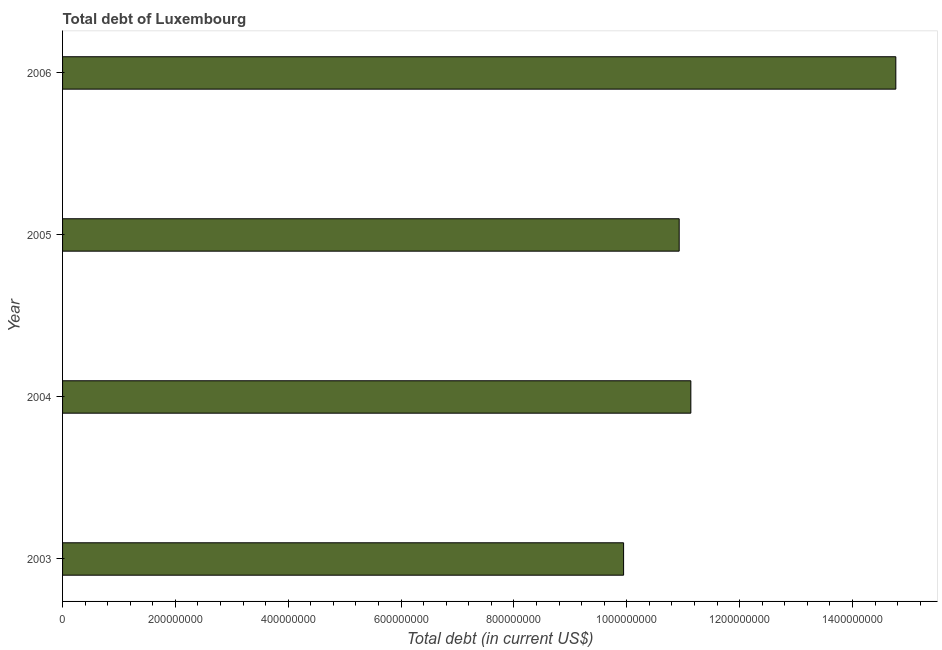What is the title of the graph?
Your answer should be very brief. Total debt of Luxembourg. What is the label or title of the X-axis?
Your answer should be compact. Total debt (in current US$). What is the total debt in 2004?
Give a very brief answer. 1.11e+09. Across all years, what is the maximum total debt?
Your answer should be very brief. 1.48e+09. Across all years, what is the minimum total debt?
Make the answer very short. 9.94e+08. In which year was the total debt minimum?
Your answer should be very brief. 2003. What is the sum of the total debt?
Your response must be concise. 4.68e+09. What is the difference between the total debt in 2004 and 2006?
Your answer should be compact. -3.63e+08. What is the average total debt per year?
Your answer should be very brief. 1.17e+09. What is the median total debt?
Give a very brief answer. 1.10e+09. In how many years, is the total debt greater than 80000000 US$?
Your answer should be compact. 4. What is the ratio of the total debt in 2003 to that in 2004?
Offer a very short reply. 0.89. Is the total debt in 2003 less than that in 2006?
Your answer should be compact. Yes. Is the difference between the total debt in 2004 and 2005 greater than the difference between any two years?
Provide a short and direct response. No. What is the difference between the highest and the second highest total debt?
Keep it short and to the point. 3.63e+08. What is the difference between the highest and the lowest total debt?
Your answer should be very brief. 4.82e+08. In how many years, is the total debt greater than the average total debt taken over all years?
Your response must be concise. 1. How many bars are there?
Provide a succinct answer. 4. Are all the bars in the graph horizontal?
Your answer should be compact. Yes. How many years are there in the graph?
Give a very brief answer. 4. What is the Total debt (in current US$) in 2003?
Keep it short and to the point. 9.94e+08. What is the Total debt (in current US$) in 2004?
Your answer should be compact. 1.11e+09. What is the Total debt (in current US$) in 2005?
Offer a very short reply. 1.09e+09. What is the Total debt (in current US$) in 2006?
Make the answer very short. 1.48e+09. What is the difference between the Total debt (in current US$) in 2003 and 2004?
Provide a short and direct response. -1.19e+08. What is the difference between the Total debt (in current US$) in 2003 and 2005?
Give a very brief answer. -9.85e+07. What is the difference between the Total debt (in current US$) in 2003 and 2006?
Your response must be concise. -4.82e+08. What is the difference between the Total debt (in current US$) in 2004 and 2005?
Ensure brevity in your answer.  2.07e+07. What is the difference between the Total debt (in current US$) in 2004 and 2006?
Provide a short and direct response. -3.63e+08. What is the difference between the Total debt (in current US$) in 2005 and 2006?
Offer a very short reply. -3.84e+08. What is the ratio of the Total debt (in current US$) in 2003 to that in 2004?
Keep it short and to the point. 0.89. What is the ratio of the Total debt (in current US$) in 2003 to that in 2005?
Provide a short and direct response. 0.91. What is the ratio of the Total debt (in current US$) in 2003 to that in 2006?
Give a very brief answer. 0.67. What is the ratio of the Total debt (in current US$) in 2004 to that in 2005?
Provide a succinct answer. 1.02. What is the ratio of the Total debt (in current US$) in 2004 to that in 2006?
Provide a succinct answer. 0.75. What is the ratio of the Total debt (in current US$) in 2005 to that in 2006?
Your answer should be compact. 0.74. 